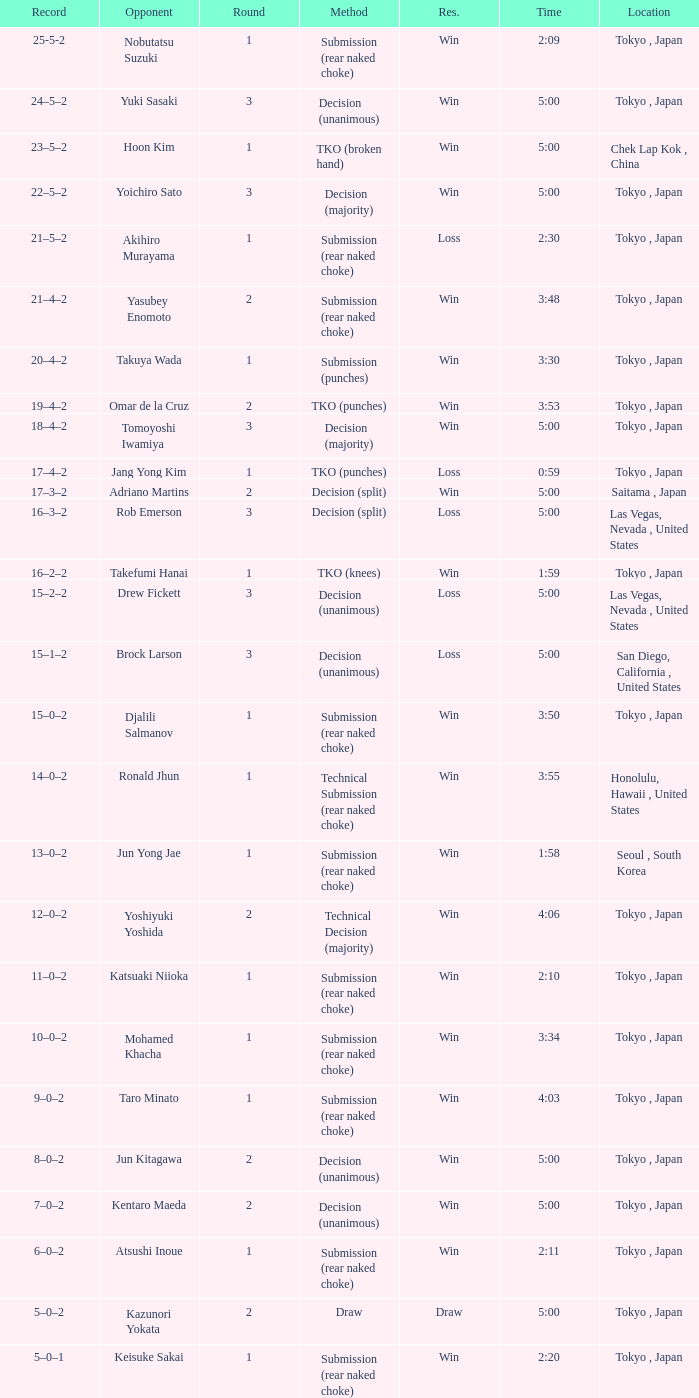What approach featured adriano martins as an adversary and a span of 5:00? Decision (split). 